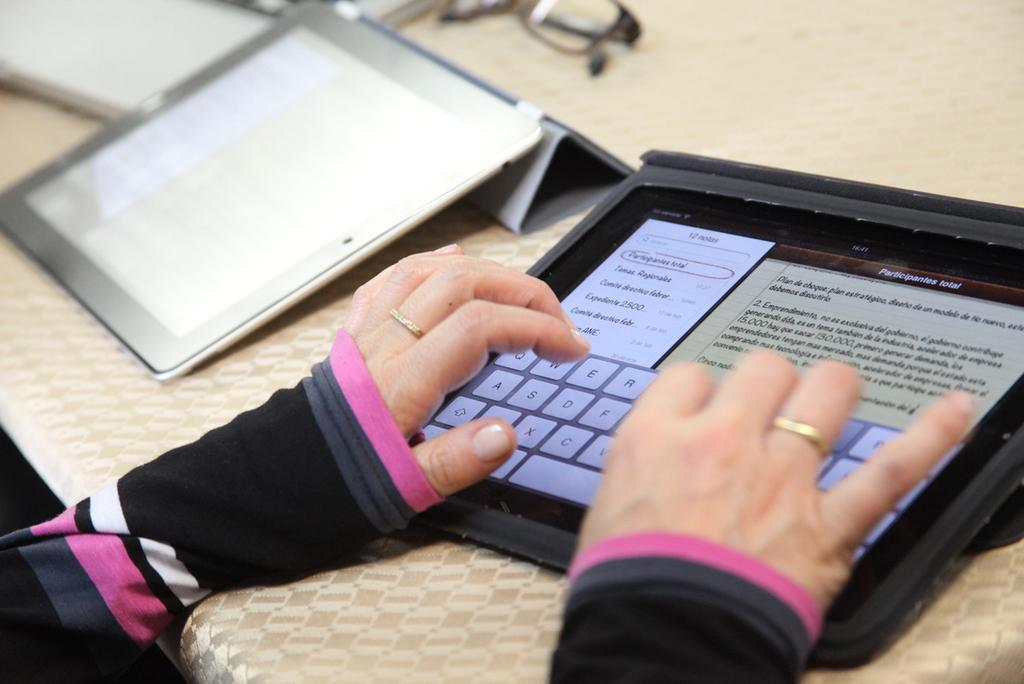What is the main object in the image? The image contains a table. What is covering the table? The table is covered with a cloth. What electronic devices are on the table? There are two tablets on the table. What is another object on the table? There is a pair of spectacles on the table. Are there any other items on the table? Yes, there are other objects on the table. Whose hands are visible in the image? A person's hands are visible in the image. Can you describe the growth of the ocean in the image? There is no ocean present in the image, so it is not possible to describe the growth of the ocean. 